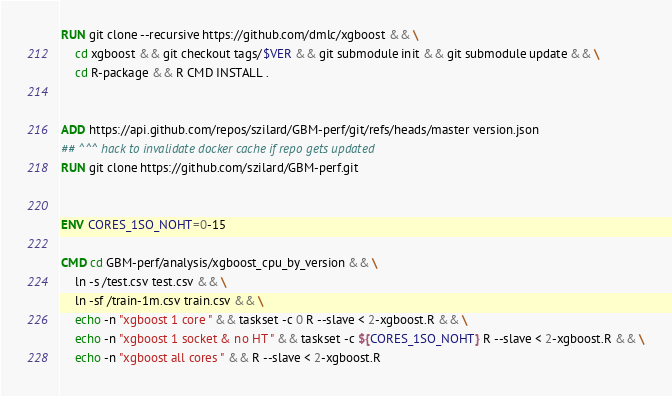Convert code to text. <code><loc_0><loc_0><loc_500><loc_500><_Dockerfile_>
RUN git clone --recursive https://github.com/dmlc/xgboost && \
    cd xgboost && git checkout tags/$VER && git submodule init && git submodule update && \
    cd R-package && R CMD INSTALL .


ADD https://api.github.com/repos/szilard/GBM-perf/git/refs/heads/master version.json
## ^^^ hack to invalidate docker cache if repo gets updated
RUN git clone https://github.com/szilard/GBM-perf.git


ENV CORES_1SO_NOHT=0-15

CMD cd GBM-perf/analysis/xgboost_cpu_by_version && \
    ln -s /test.csv test.csv && \
    ln -sf /train-1m.csv train.csv && \
    echo -n "xgboost 1 core " && taskset -c 0 R --slave < 2-xgboost.R && \
    echo -n "xgboost 1 socket & no HT " && taskset -c ${CORES_1SO_NOHT} R --slave < 2-xgboost.R && \
    echo -n "xgboost all cores " && R --slave < 2-xgboost.R 

</code> 